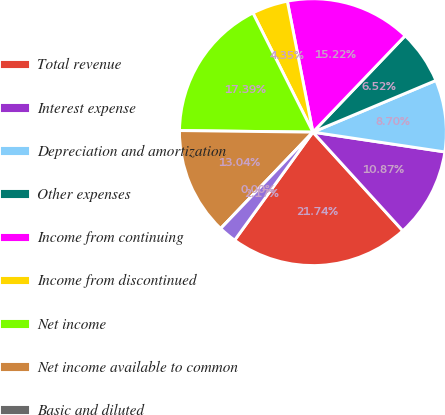Convert chart to OTSL. <chart><loc_0><loc_0><loc_500><loc_500><pie_chart><fcel>Total revenue<fcel>Interest expense<fcel>Depreciation and amortization<fcel>Other expenses<fcel>Income from continuing<fcel>Income from discontinued<fcel>Net income<fcel>Net income available to common<fcel>Basic and diluted<fcel>Dividends paid per common<nl><fcel>21.74%<fcel>10.87%<fcel>8.7%<fcel>6.52%<fcel>15.22%<fcel>4.35%<fcel>17.39%<fcel>13.04%<fcel>0.0%<fcel>2.17%<nl></chart> 